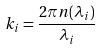Convert formula to latex. <formula><loc_0><loc_0><loc_500><loc_500>k _ { i } = \frac { 2 \pi n ( \lambda _ { i } ) } { \lambda _ { i } }</formula> 